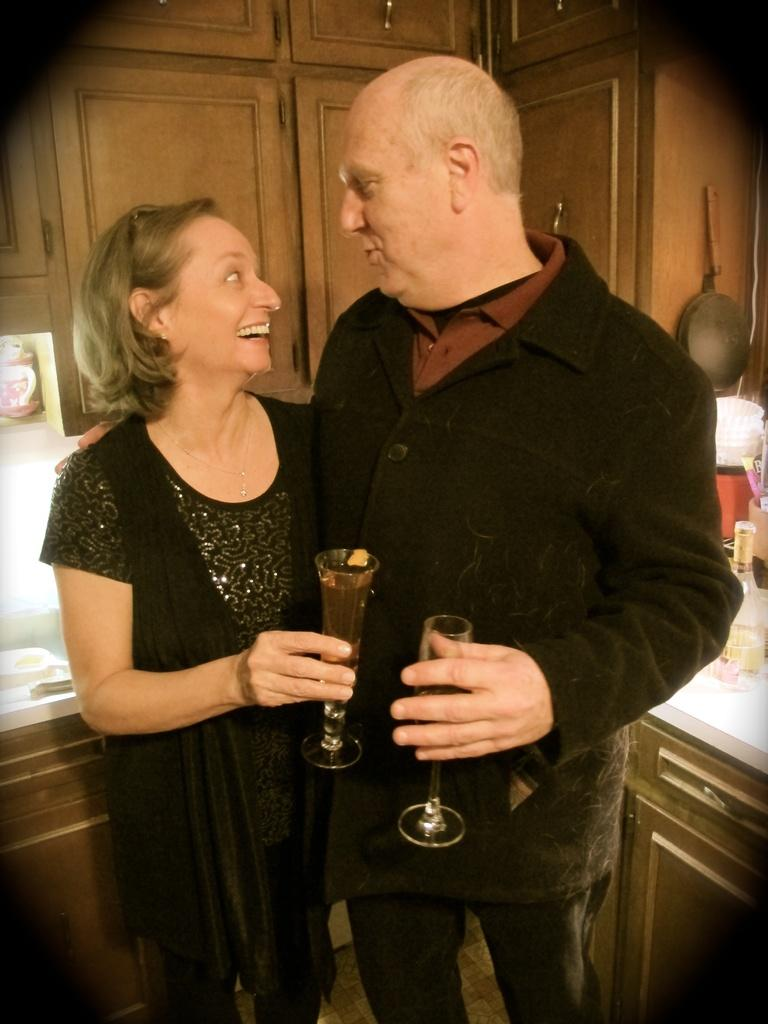How many people are in the image? There are two people in the image, a woman and a man. What are the woman and the man wearing? The woman and the man are both wearing black jackets. What are the woman and the man holding in their hands? The woman and the man are holding glasses. What type of furniture can be seen in the image? There are cupboards and a table in the image. What is on the table in the image? There is a bottle on the table. What type of cloud can be seen in the image? There are no clouds present in the image; it is an indoor scene. 